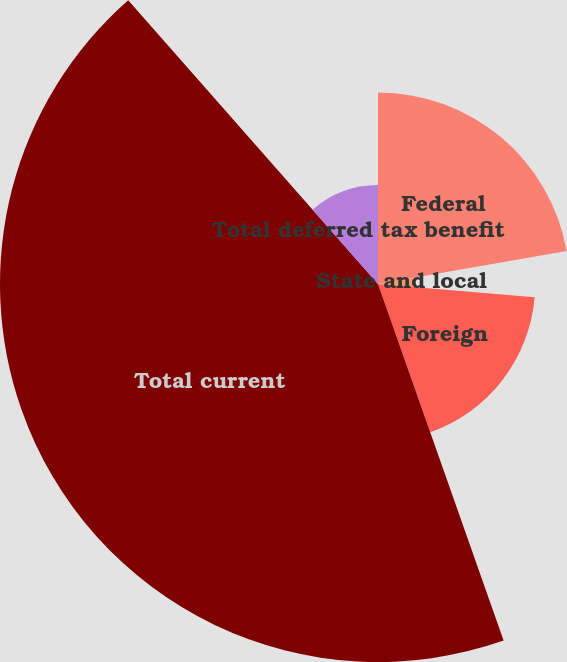Convert chart to OTSL. <chart><loc_0><loc_0><loc_500><loc_500><pie_chart><fcel>Federal<fcel>State and local<fcel>Foreign<fcel>Total current<fcel>Total deferred tax benefit<nl><fcel>22.24%<fcel>4.11%<fcel>18.26%<fcel>43.9%<fcel>11.49%<nl></chart> 